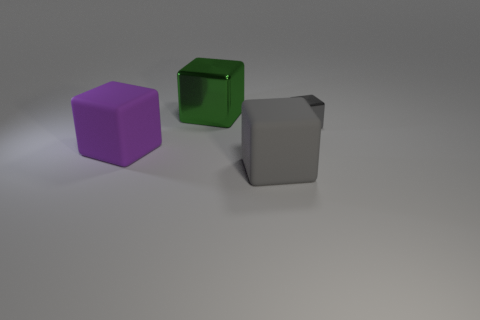How many objects are either shiny blocks to the left of the small gray cube or large metal blocks behind the big purple rubber cube?
Provide a succinct answer. 1. Are there any other things that have the same shape as the tiny metal thing?
Keep it short and to the point. Yes. There is a large rubber block to the left of the large green block; is its color the same as the metallic cube right of the big gray matte thing?
Your response must be concise. No. What number of metal objects are either yellow spheres or purple objects?
Ensure brevity in your answer.  0. Is there any other thing that has the same size as the green metal thing?
Keep it short and to the point. Yes. There is a big thing that is left of the metal block that is to the left of the gray metal object; what shape is it?
Offer a very short reply. Cube. Does the gray block that is to the left of the small metal cube have the same material as the thing that is left of the green cube?
Your answer should be compact. Yes. What number of metal blocks are to the right of the big matte object that is in front of the purple matte cube?
Give a very brief answer. 1. There is a metal thing to the right of the gray rubber object; is it the same shape as the rubber object on the right side of the large green thing?
Make the answer very short. Yes. What size is the block that is both behind the large purple matte cube and in front of the green object?
Keep it short and to the point. Small. 